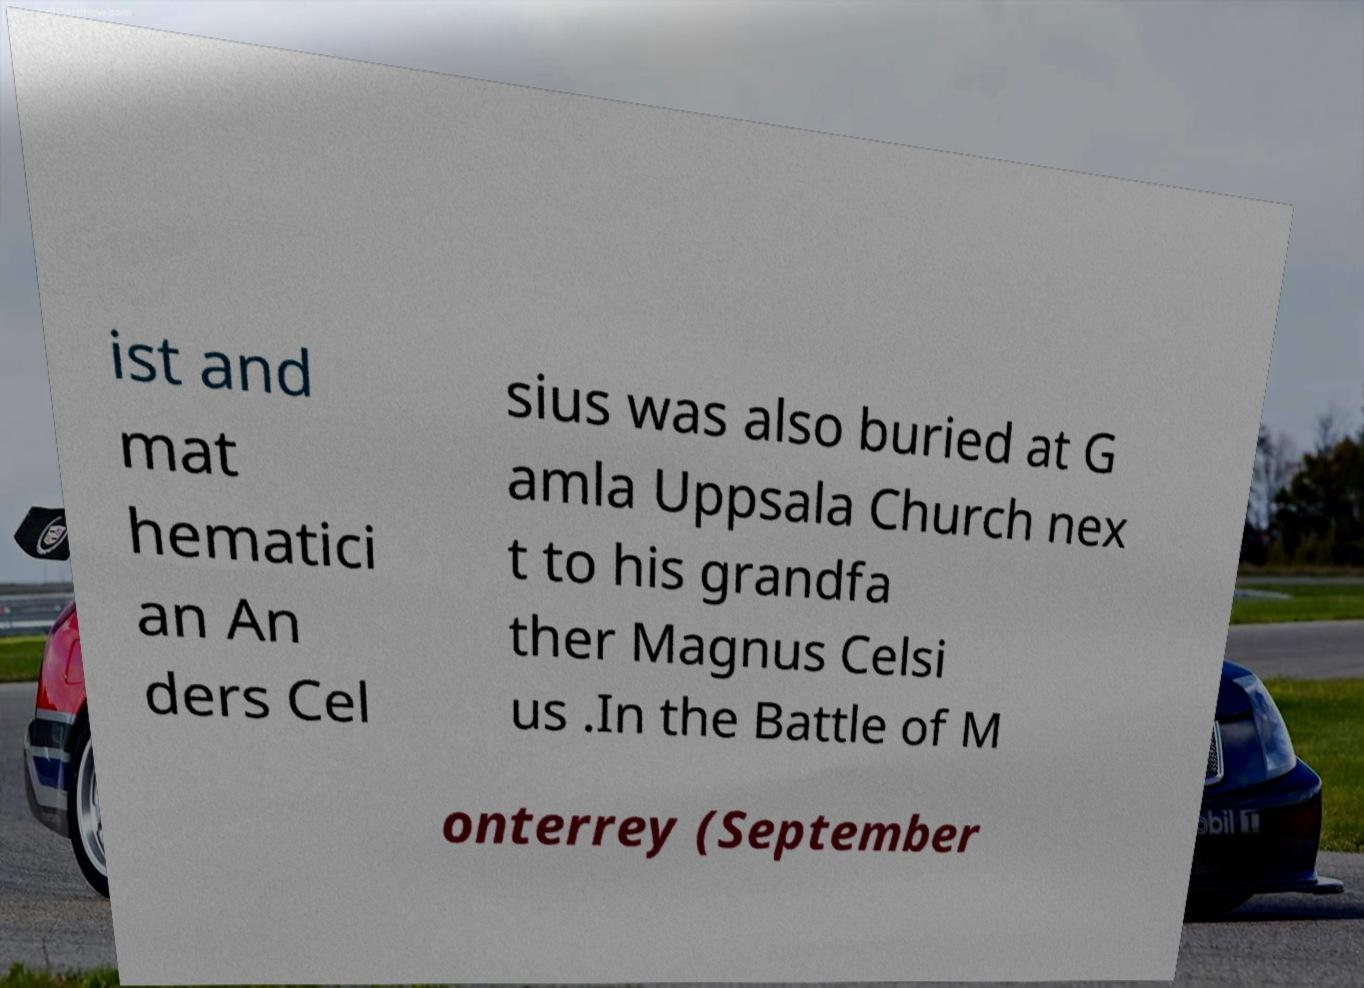Please identify and transcribe the text found in this image. ist and mat hematici an An ders Cel sius was also buried at G amla Uppsala Church nex t to his grandfa ther Magnus Celsi us .In the Battle of M onterrey (September 